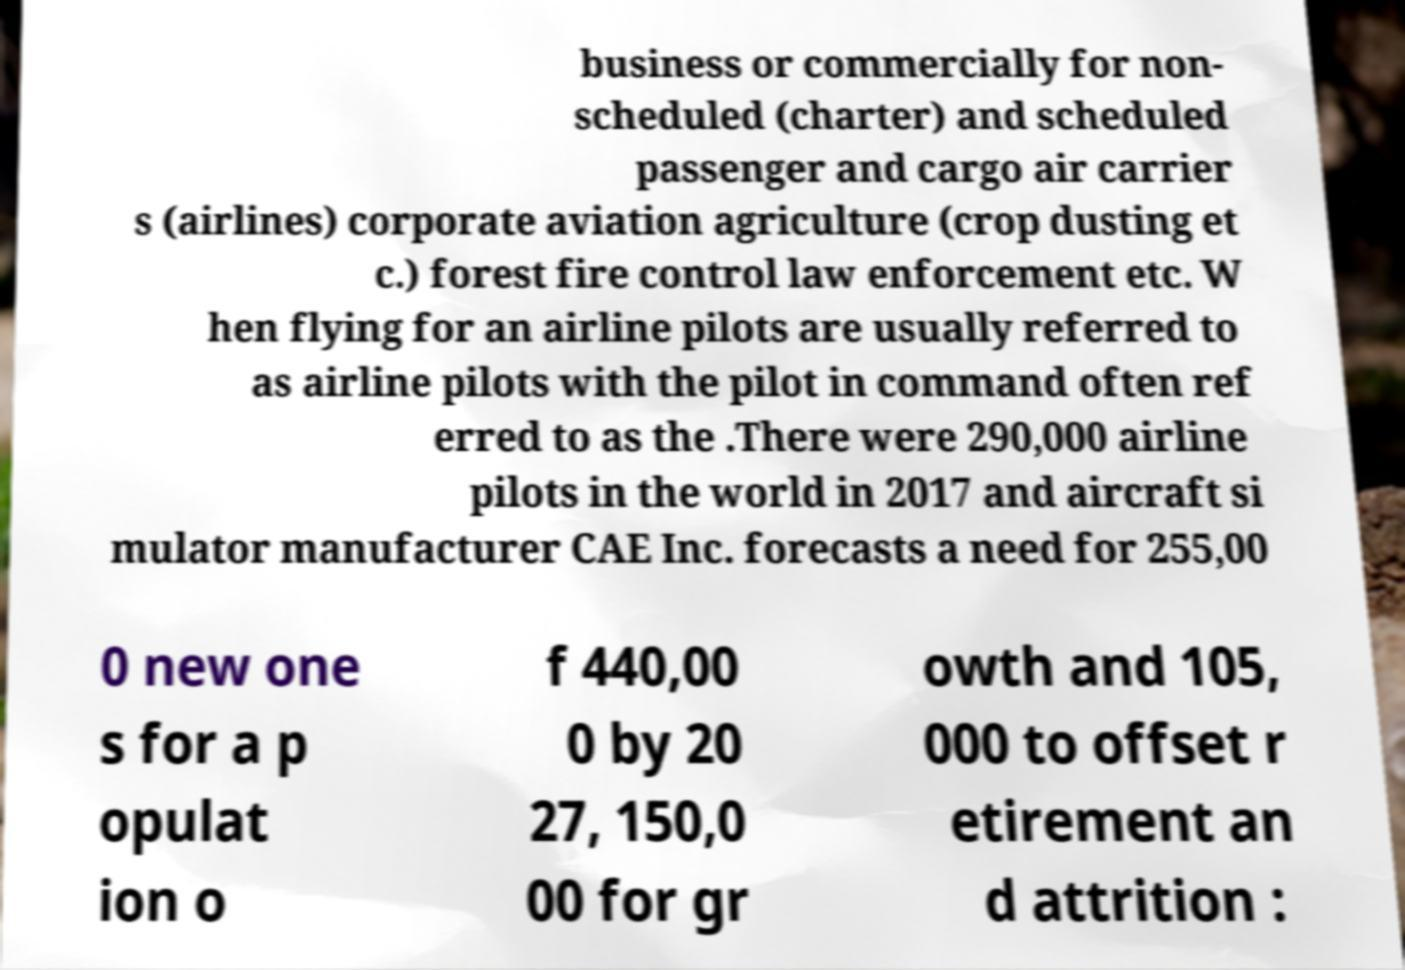What messages or text are displayed in this image? I need them in a readable, typed format. business or commercially for non- scheduled (charter) and scheduled passenger and cargo air carrier s (airlines) corporate aviation agriculture (crop dusting et c.) forest fire control law enforcement etc. W hen flying for an airline pilots are usually referred to as airline pilots with the pilot in command often ref erred to as the .There were 290,000 airline pilots in the world in 2017 and aircraft si mulator manufacturer CAE Inc. forecasts a need for 255,00 0 new one s for a p opulat ion o f 440,00 0 by 20 27, 150,0 00 for gr owth and 105, 000 to offset r etirement an d attrition : 